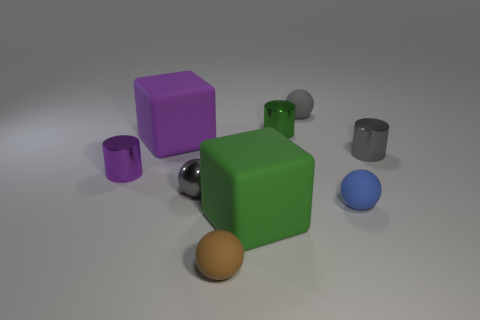Add 1 small gray metal cylinders. How many objects exist? 10 Subtract all balls. How many objects are left? 5 Subtract all large purple metal balls. Subtract all small green objects. How many objects are left? 8 Add 8 tiny green objects. How many tiny green objects are left? 9 Add 7 small purple matte objects. How many small purple matte objects exist? 7 Subtract 0 blue blocks. How many objects are left? 9 